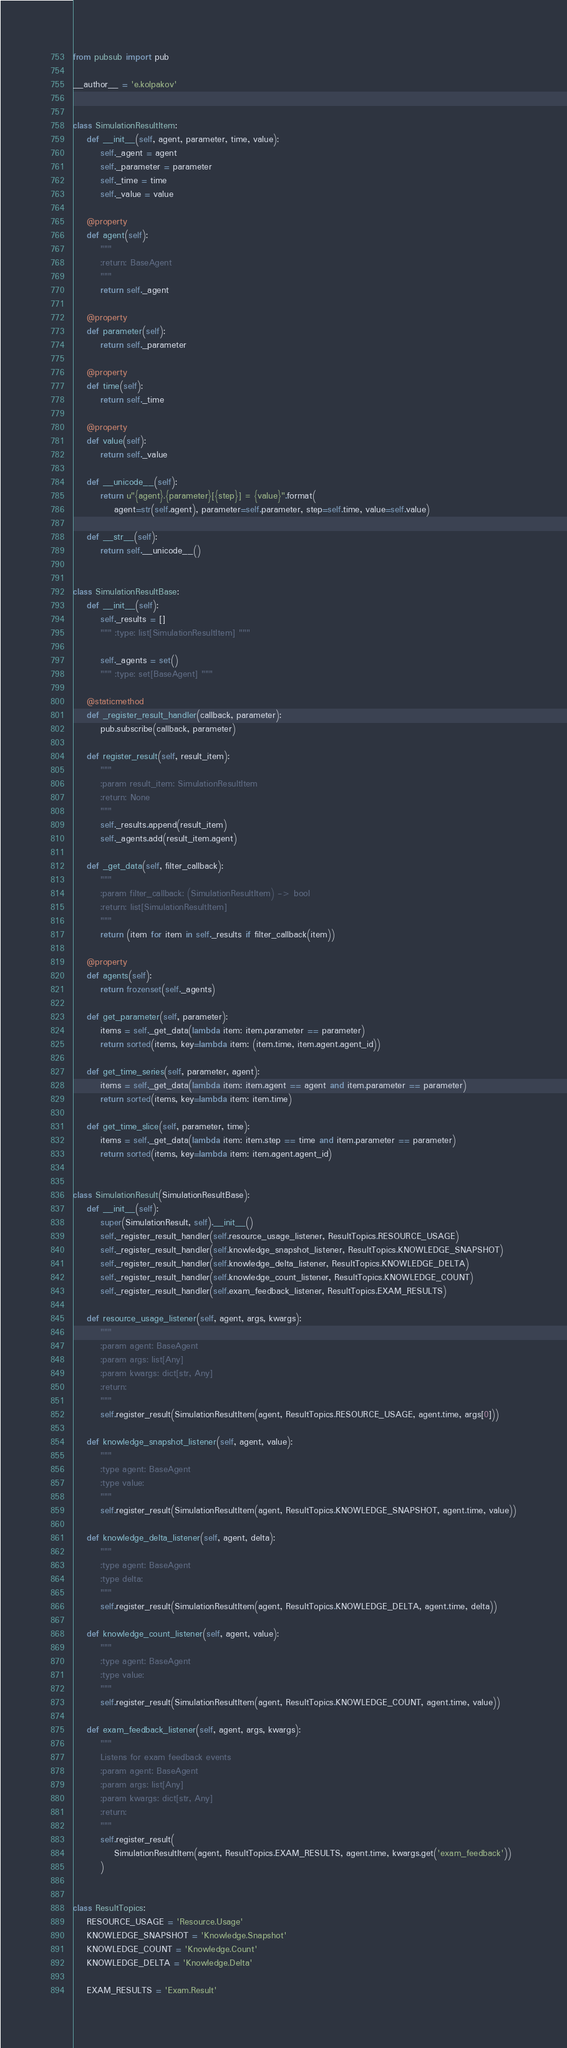<code> <loc_0><loc_0><loc_500><loc_500><_Python_>from pubsub import pub

__author__ = 'e.kolpakov'


class SimulationResultItem:
    def __init__(self, agent, parameter, time, value):
        self._agent = agent
        self._parameter = parameter
        self._time = time
        self._value = value

    @property
    def agent(self):
        """
        :return: BaseAgent
        """
        return self._agent

    @property
    def parameter(self):
        return self._parameter

    @property
    def time(self):
        return self._time

    @property
    def value(self):
        return self._value

    def __unicode__(self):
        return u"{agent}.{parameter}[{step}] = {value}".format(
            agent=str(self.agent), parameter=self.parameter, step=self.time, value=self.value)

    def __str__(self):
        return self.__unicode__()


class SimulationResultBase:
    def __init__(self):
        self._results = []
        """ :type: list[SimulationResultItem] """

        self._agents = set()
        """ :type: set[BaseAgent] """

    @staticmethod
    def _register_result_handler(callback, parameter):
        pub.subscribe(callback, parameter)

    def register_result(self, result_item):
        """
        :param result_item: SimulationResultItem
        :return: None
        """
        self._results.append(result_item)
        self._agents.add(result_item.agent)

    def _get_data(self, filter_callback):
        """
        :param filter_callback: (SimulationResultItem) -> bool
        :return: list[SimulationResultItem]
        """
        return (item for item in self._results if filter_callback(item))

    @property
    def agents(self):
        return frozenset(self._agents)

    def get_parameter(self, parameter):
        items = self._get_data(lambda item: item.parameter == parameter)
        return sorted(items, key=lambda item: (item.time, item.agent.agent_id))

    def get_time_series(self, parameter, agent):
        items = self._get_data(lambda item: item.agent == agent and item.parameter == parameter)
        return sorted(items, key=lambda item: item.time)

    def get_time_slice(self, parameter, time):
        items = self._get_data(lambda item: item.step == time and item.parameter == parameter)
        return sorted(items, key=lambda item: item.agent.agent_id)


class SimulationResult(SimulationResultBase):
    def __init__(self):
        super(SimulationResult, self).__init__()
        self._register_result_handler(self.resource_usage_listener, ResultTopics.RESOURCE_USAGE)
        self._register_result_handler(self.knowledge_snapshot_listener, ResultTopics.KNOWLEDGE_SNAPSHOT)
        self._register_result_handler(self.knowledge_delta_listener, ResultTopics.KNOWLEDGE_DELTA)
        self._register_result_handler(self.knowledge_count_listener, ResultTopics.KNOWLEDGE_COUNT)
        self._register_result_handler(self.exam_feedback_listener, ResultTopics.EXAM_RESULTS)

    def resource_usage_listener(self, agent, args, kwargs):
        """
        :param agent: BaseAgent
        :param args: list[Any]
        :param kwargs: dict[str, Any]
        :return:
        """
        self.register_result(SimulationResultItem(agent, ResultTopics.RESOURCE_USAGE, agent.time, args[0]))

    def knowledge_snapshot_listener(self, agent, value):
        """
        :type agent: BaseAgent
        :type value:
        """
        self.register_result(SimulationResultItem(agent, ResultTopics.KNOWLEDGE_SNAPSHOT, agent.time, value))

    def knowledge_delta_listener(self, agent, delta):
        """
        :type agent: BaseAgent
        :type delta:
        """
        self.register_result(SimulationResultItem(agent, ResultTopics.KNOWLEDGE_DELTA, agent.time, delta))

    def knowledge_count_listener(self, agent, value):
        """
        :type agent: BaseAgent
        :type value:
        """
        self.register_result(SimulationResultItem(agent, ResultTopics.KNOWLEDGE_COUNT, agent.time, value))

    def exam_feedback_listener(self, agent, args, kwargs):
        """
        Listens for exam feedback events
        :param agent: BaseAgent
        :param args: list[Any]
        :param kwargs: dict[str, Any]
        :return:
        """
        self.register_result(
            SimulationResultItem(agent, ResultTopics.EXAM_RESULTS, agent.time, kwargs.get('exam_feedback'))
        )


class ResultTopics:
    RESOURCE_USAGE = 'Resource.Usage'
    KNOWLEDGE_SNAPSHOT = 'Knowledge.Snapshot'
    KNOWLEDGE_COUNT = 'Knowledge.Count'
    KNOWLEDGE_DELTA = 'Knowledge.Delta'

    EXAM_RESULTS = 'Exam.Result'
</code> 